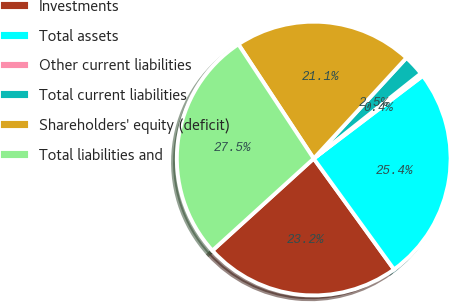Convert chart. <chart><loc_0><loc_0><loc_500><loc_500><pie_chart><fcel>Investments<fcel>Total assets<fcel>Other current liabilities<fcel>Total current liabilities<fcel>Shareholders' equity (deficit)<fcel>Total liabilities and<nl><fcel>23.24%<fcel>25.35%<fcel>0.36%<fcel>2.47%<fcel>21.12%<fcel>27.46%<nl></chart> 